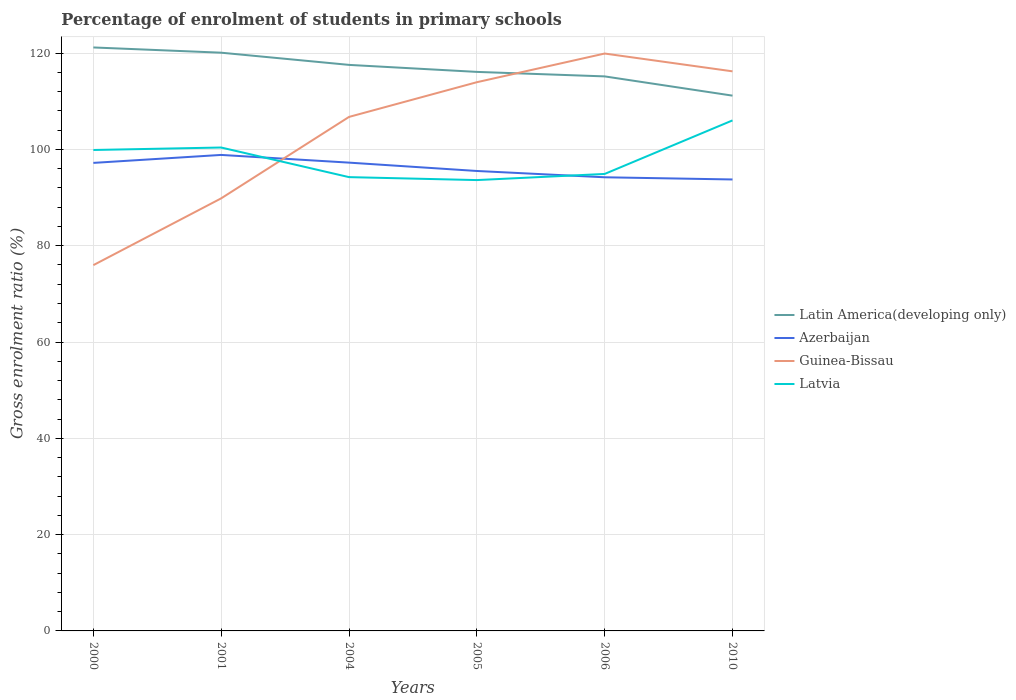How many different coloured lines are there?
Give a very brief answer. 4. Does the line corresponding to Guinea-Bissau intersect with the line corresponding to Latin America(developing only)?
Your answer should be very brief. Yes. Across all years, what is the maximum percentage of students enrolled in primary schools in Latin America(developing only)?
Keep it short and to the point. 111.17. In which year was the percentage of students enrolled in primary schools in Azerbaijan maximum?
Provide a short and direct response. 2010. What is the total percentage of students enrolled in primary schools in Latvia in the graph?
Your answer should be compact. -11.12. What is the difference between the highest and the second highest percentage of students enrolled in primary schools in Latvia?
Ensure brevity in your answer.  12.39. How many lines are there?
Your answer should be compact. 4. How many years are there in the graph?
Ensure brevity in your answer.  6. Are the values on the major ticks of Y-axis written in scientific E-notation?
Your answer should be very brief. No. Where does the legend appear in the graph?
Your response must be concise. Center right. What is the title of the graph?
Your response must be concise. Percentage of enrolment of students in primary schools. What is the label or title of the X-axis?
Ensure brevity in your answer.  Years. What is the Gross enrolment ratio (%) in Latin America(developing only) in 2000?
Your answer should be very brief. 121.18. What is the Gross enrolment ratio (%) in Azerbaijan in 2000?
Ensure brevity in your answer.  97.21. What is the Gross enrolment ratio (%) in Guinea-Bissau in 2000?
Ensure brevity in your answer.  75.97. What is the Gross enrolment ratio (%) in Latvia in 2000?
Provide a succinct answer. 99.89. What is the Gross enrolment ratio (%) in Latin America(developing only) in 2001?
Offer a terse response. 120.09. What is the Gross enrolment ratio (%) of Azerbaijan in 2001?
Make the answer very short. 98.86. What is the Gross enrolment ratio (%) in Guinea-Bissau in 2001?
Offer a terse response. 89.84. What is the Gross enrolment ratio (%) in Latvia in 2001?
Keep it short and to the point. 100.4. What is the Gross enrolment ratio (%) in Latin America(developing only) in 2004?
Your response must be concise. 117.56. What is the Gross enrolment ratio (%) in Azerbaijan in 2004?
Provide a short and direct response. 97.26. What is the Gross enrolment ratio (%) of Guinea-Bissau in 2004?
Make the answer very short. 106.76. What is the Gross enrolment ratio (%) of Latvia in 2004?
Provide a short and direct response. 94.25. What is the Gross enrolment ratio (%) of Latin America(developing only) in 2005?
Your response must be concise. 116.11. What is the Gross enrolment ratio (%) of Azerbaijan in 2005?
Offer a very short reply. 95.53. What is the Gross enrolment ratio (%) in Guinea-Bissau in 2005?
Provide a succinct answer. 113.96. What is the Gross enrolment ratio (%) in Latvia in 2005?
Your answer should be very brief. 93.64. What is the Gross enrolment ratio (%) of Latin America(developing only) in 2006?
Make the answer very short. 115.17. What is the Gross enrolment ratio (%) in Azerbaijan in 2006?
Provide a short and direct response. 94.22. What is the Gross enrolment ratio (%) in Guinea-Bissau in 2006?
Your answer should be very brief. 119.92. What is the Gross enrolment ratio (%) in Latvia in 2006?
Offer a terse response. 94.91. What is the Gross enrolment ratio (%) of Latin America(developing only) in 2010?
Make the answer very short. 111.17. What is the Gross enrolment ratio (%) of Azerbaijan in 2010?
Make the answer very short. 93.76. What is the Gross enrolment ratio (%) of Guinea-Bissau in 2010?
Provide a short and direct response. 116.22. What is the Gross enrolment ratio (%) of Latvia in 2010?
Your response must be concise. 106.03. Across all years, what is the maximum Gross enrolment ratio (%) of Latin America(developing only)?
Provide a succinct answer. 121.18. Across all years, what is the maximum Gross enrolment ratio (%) of Azerbaijan?
Provide a succinct answer. 98.86. Across all years, what is the maximum Gross enrolment ratio (%) in Guinea-Bissau?
Provide a succinct answer. 119.92. Across all years, what is the maximum Gross enrolment ratio (%) of Latvia?
Provide a succinct answer. 106.03. Across all years, what is the minimum Gross enrolment ratio (%) in Latin America(developing only)?
Ensure brevity in your answer.  111.17. Across all years, what is the minimum Gross enrolment ratio (%) of Azerbaijan?
Make the answer very short. 93.76. Across all years, what is the minimum Gross enrolment ratio (%) of Guinea-Bissau?
Give a very brief answer. 75.97. Across all years, what is the minimum Gross enrolment ratio (%) of Latvia?
Give a very brief answer. 93.64. What is the total Gross enrolment ratio (%) in Latin America(developing only) in the graph?
Offer a very short reply. 701.29. What is the total Gross enrolment ratio (%) of Azerbaijan in the graph?
Your response must be concise. 576.84. What is the total Gross enrolment ratio (%) in Guinea-Bissau in the graph?
Offer a terse response. 622.67. What is the total Gross enrolment ratio (%) of Latvia in the graph?
Your response must be concise. 589.12. What is the difference between the Gross enrolment ratio (%) of Latin America(developing only) in 2000 and that in 2001?
Your answer should be compact. 1.09. What is the difference between the Gross enrolment ratio (%) in Azerbaijan in 2000 and that in 2001?
Give a very brief answer. -1.65. What is the difference between the Gross enrolment ratio (%) in Guinea-Bissau in 2000 and that in 2001?
Provide a succinct answer. -13.87. What is the difference between the Gross enrolment ratio (%) of Latvia in 2000 and that in 2001?
Make the answer very short. -0.51. What is the difference between the Gross enrolment ratio (%) of Latin America(developing only) in 2000 and that in 2004?
Offer a terse response. 3.62. What is the difference between the Gross enrolment ratio (%) in Azerbaijan in 2000 and that in 2004?
Ensure brevity in your answer.  -0.05. What is the difference between the Gross enrolment ratio (%) of Guinea-Bissau in 2000 and that in 2004?
Keep it short and to the point. -30.79. What is the difference between the Gross enrolment ratio (%) of Latvia in 2000 and that in 2004?
Keep it short and to the point. 5.64. What is the difference between the Gross enrolment ratio (%) in Latin America(developing only) in 2000 and that in 2005?
Provide a succinct answer. 5.07. What is the difference between the Gross enrolment ratio (%) of Azerbaijan in 2000 and that in 2005?
Offer a terse response. 1.68. What is the difference between the Gross enrolment ratio (%) in Guinea-Bissau in 2000 and that in 2005?
Offer a terse response. -37.99. What is the difference between the Gross enrolment ratio (%) of Latvia in 2000 and that in 2005?
Offer a very short reply. 6.25. What is the difference between the Gross enrolment ratio (%) in Latin America(developing only) in 2000 and that in 2006?
Your answer should be compact. 6.01. What is the difference between the Gross enrolment ratio (%) of Azerbaijan in 2000 and that in 2006?
Ensure brevity in your answer.  2.99. What is the difference between the Gross enrolment ratio (%) in Guinea-Bissau in 2000 and that in 2006?
Keep it short and to the point. -43.95. What is the difference between the Gross enrolment ratio (%) in Latvia in 2000 and that in 2006?
Your answer should be very brief. 4.97. What is the difference between the Gross enrolment ratio (%) in Latin America(developing only) in 2000 and that in 2010?
Offer a very short reply. 10.01. What is the difference between the Gross enrolment ratio (%) in Azerbaijan in 2000 and that in 2010?
Make the answer very short. 3.45. What is the difference between the Gross enrolment ratio (%) in Guinea-Bissau in 2000 and that in 2010?
Provide a short and direct response. -40.25. What is the difference between the Gross enrolment ratio (%) in Latvia in 2000 and that in 2010?
Make the answer very short. -6.15. What is the difference between the Gross enrolment ratio (%) of Latin America(developing only) in 2001 and that in 2004?
Offer a very short reply. 2.53. What is the difference between the Gross enrolment ratio (%) in Azerbaijan in 2001 and that in 2004?
Keep it short and to the point. 1.6. What is the difference between the Gross enrolment ratio (%) in Guinea-Bissau in 2001 and that in 2004?
Make the answer very short. -16.91. What is the difference between the Gross enrolment ratio (%) in Latvia in 2001 and that in 2004?
Make the answer very short. 6.15. What is the difference between the Gross enrolment ratio (%) in Latin America(developing only) in 2001 and that in 2005?
Your answer should be very brief. 3.99. What is the difference between the Gross enrolment ratio (%) in Azerbaijan in 2001 and that in 2005?
Make the answer very short. 3.33. What is the difference between the Gross enrolment ratio (%) of Guinea-Bissau in 2001 and that in 2005?
Ensure brevity in your answer.  -24.12. What is the difference between the Gross enrolment ratio (%) of Latvia in 2001 and that in 2005?
Ensure brevity in your answer.  6.76. What is the difference between the Gross enrolment ratio (%) in Latin America(developing only) in 2001 and that in 2006?
Provide a short and direct response. 4.92. What is the difference between the Gross enrolment ratio (%) of Azerbaijan in 2001 and that in 2006?
Give a very brief answer. 4.64. What is the difference between the Gross enrolment ratio (%) of Guinea-Bissau in 2001 and that in 2006?
Your answer should be very brief. -30.08. What is the difference between the Gross enrolment ratio (%) in Latvia in 2001 and that in 2006?
Provide a succinct answer. 5.49. What is the difference between the Gross enrolment ratio (%) in Latin America(developing only) in 2001 and that in 2010?
Provide a short and direct response. 8.92. What is the difference between the Gross enrolment ratio (%) of Azerbaijan in 2001 and that in 2010?
Your answer should be very brief. 5.1. What is the difference between the Gross enrolment ratio (%) of Guinea-Bissau in 2001 and that in 2010?
Your answer should be very brief. -26.38. What is the difference between the Gross enrolment ratio (%) in Latvia in 2001 and that in 2010?
Give a very brief answer. -5.63. What is the difference between the Gross enrolment ratio (%) of Latin America(developing only) in 2004 and that in 2005?
Offer a terse response. 1.45. What is the difference between the Gross enrolment ratio (%) in Azerbaijan in 2004 and that in 2005?
Give a very brief answer. 1.73. What is the difference between the Gross enrolment ratio (%) in Guinea-Bissau in 2004 and that in 2005?
Your response must be concise. -7.21. What is the difference between the Gross enrolment ratio (%) in Latvia in 2004 and that in 2005?
Offer a very short reply. 0.61. What is the difference between the Gross enrolment ratio (%) in Latin America(developing only) in 2004 and that in 2006?
Give a very brief answer. 2.39. What is the difference between the Gross enrolment ratio (%) in Azerbaijan in 2004 and that in 2006?
Your answer should be very brief. 3.04. What is the difference between the Gross enrolment ratio (%) in Guinea-Bissau in 2004 and that in 2006?
Your answer should be compact. -13.16. What is the difference between the Gross enrolment ratio (%) of Latvia in 2004 and that in 2006?
Provide a short and direct response. -0.66. What is the difference between the Gross enrolment ratio (%) of Latin America(developing only) in 2004 and that in 2010?
Give a very brief answer. 6.39. What is the difference between the Gross enrolment ratio (%) of Azerbaijan in 2004 and that in 2010?
Provide a short and direct response. 3.5. What is the difference between the Gross enrolment ratio (%) in Guinea-Bissau in 2004 and that in 2010?
Give a very brief answer. -9.47. What is the difference between the Gross enrolment ratio (%) of Latvia in 2004 and that in 2010?
Your answer should be very brief. -11.78. What is the difference between the Gross enrolment ratio (%) in Latin America(developing only) in 2005 and that in 2006?
Offer a terse response. 0.93. What is the difference between the Gross enrolment ratio (%) of Azerbaijan in 2005 and that in 2006?
Provide a succinct answer. 1.31. What is the difference between the Gross enrolment ratio (%) of Guinea-Bissau in 2005 and that in 2006?
Give a very brief answer. -5.95. What is the difference between the Gross enrolment ratio (%) of Latvia in 2005 and that in 2006?
Ensure brevity in your answer.  -1.27. What is the difference between the Gross enrolment ratio (%) of Latin America(developing only) in 2005 and that in 2010?
Your answer should be very brief. 4.93. What is the difference between the Gross enrolment ratio (%) of Azerbaijan in 2005 and that in 2010?
Provide a short and direct response. 1.76. What is the difference between the Gross enrolment ratio (%) of Guinea-Bissau in 2005 and that in 2010?
Offer a terse response. -2.26. What is the difference between the Gross enrolment ratio (%) of Latvia in 2005 and that in 2010?
Keep it short and to the point. -12.39. What is the difference between the Gross enrolment ratio (%) in Latin America(developing only) in 2006 and that in 2010?
Give a very brief answer. 4. What is the difference between the Gross enrolment ratio (%) of Azerbaijan in 2006 and that in 2010?
Give a very brief answer. 0.45. What is the difference between the Gross enrolment ratio (%) of Guinea-Bissau in 2006 and that in 2010?
Give a very brief answer. 3.7. What is the difference between the Gross enrolment ratio (%) in Latvia in 2006 and that in 2010?
Make the answer very short. -11.12. What is the difference between the Gross enrolment ratio (%) of Latin America(developing only) in 2000 and the Gross enrolment ratio (%) of Azerbaijan in 2001?
Your answer should be compact. 22.32. What is the difference between the Gross enrolment ratio (%) in Latin America(developing only) in 2000 and the Gross enrolment ratio (%) in Guinea-Bissau in 2001?
Keep it short and to the point. 31.34. What is the difference between the Gross enrolment ratio (%) of Latin America(developing only) in 2000 and the Gross enrolment ratio (%) of Latvia in 2001?
Your answer should be compact. 20.78. What is the difference between the Gross enrolment ratio (%) of Azerbaijan in 2000 and the Gross enrolment ratio (%) of Guinea-Bissau in 2001?
Give a very brief answer. 7.37. What is the difference between the Gross enrolment ratio (%) in Azerbaijan in 2000 and the Gross enrolment ratio (%) in Latvia in 2001?
Offer a very short reply. -3.19. What is the difference between the Gross enrolment ratio (%) in Guinea-Bissau in 2000 and the Gross enrolment ratio (%) in Latvia in 2001?
Your answer should be compact. -24.43. What is the difference between the Gross enrolment ratio (%) of Latin America(developing only) in 2000 and the Gross enrolment ratio (%) of Azerbaijan in 2004?
Make the answer very short. 23.92. What is the difference between the Gross enrolment ratio (%) of Latin America(developing only) in 2000 and the Gross enrolment ratio (%) of Guinea-Bissau in 2004?
Provide a short and direct response. 14.43. What is the difference between the Gross enrolment ratio (%) of Latin America(developing only) in 2000 and the Gross enrolment ratio (%) of Latvia in 2004?
Your response must be concise. 26.93. What is the difference between the Gross enrolment ratio (%) of Azerbaijan in 2000 and the Gross enrolment ratio (%) of Guinea-Bissau in 2004?
Make the answer very short. -9.55. What is the difference between the Gross enrolment ratio (%) in Azerbaijan in 2000 and the Gross enrolment ratio (%) in Latvia in 2004?
Offer a terse response. 2.96. What is the difference between the Gross enrolment ratio (%) of Guinea-Bissau in 2000 and the Gross enrolment ratio (%) of Latvia in 2004?
Your response must be concise. -18.28. What is the difference between the Gross enrolment ratio (%) of Latin America(developing only) in 2000 and the Gross enrolment ratio (%) of Azerbaijan in 2005?
Offer a very short reply. 25.65. What is the difference between the Gross enrolment ratio (%) of Latin America(developing only) in 2000 and the Gross enrolment ratio (%) of Guinea-Bissau in 2005?
Give a very brief answer. 7.22. What is the difference between the Gross enrolment ratio (%) in Latin America(developing only) in 2000 and the Gross enrolment ratio (%) in Latvia in 2005?
Provide a short and direct response. 27.54. What is the difference between the Gross enrolment ratio (%) of Azerbaijan in 2000 and the Gross enrolment ratio (%) of Guinea-Bissau in 2005?
Offer a very short reply. -16.76. What is the difference between the Gross enrolment ratio (%) of Azerbaijan in 2000 and the Gross enrolment ratio (%) of Latvia in 2005?
Offer a very short reply. 3.57. What is the difference between the Gross enrolment ratio (%) of Guinea-Bissau in 2000 and the Gross enrolment ratio (%) of Latvia in 2005?
Make the answer very short. -17.67. What is the difference between the Gross enrolment ratio (%) of Latin America(developing only) in 2000 and the Gross enrolment ratio (%) of Azerbaijan in 2006?
Make the answer very short. 26.96. What is the difference between the Gross enrolment ratio (%) in Latin America(developing only) in 2000 and the Gross enrolment ratio (%) in Guinea-Bissau in 2006?
Your answer should be very brief. 1.26. What is the difference between the Gross enrolment ratio (%) in Latin America(developing only) in 2000 and the Gross enrolment ratio (%) in Latvia in 2006?
Offer a terse response. 26.27. What is the difference between the Gross enrolment ratio (%) in Azerbaijan in 2000 and the Gross enrolment ratio (%) in Guinea-Bissau in 2006?
Offer a very short reply. -22.71. What is the difference between the Gross enrolment ratio (%) in Azerbaijan in 2000 and the Gross enrolment ratio (%) in Latvia in 2006?
Your answer should be very brief. 2.3. What is the difference between the Gross enrolment ratio (%) of Guinea-Bissau in 2000 and the Gross enrolment ratio (%) of Latvia in 2006?
Ensure brevity in your answer.  -18.94. What is the difference between the Gross enrolment ratio (%) of Latin America(developing only) in 2000 and the Gross enrolment ratio (%) of Azerbaijan in 2010?
Your response must be concise. 27.42. What is the difference between the Gross enrolment ratio (%) of Latin America(developing only) in 2000 and the Gross enrolment ratio (%) of Guinea-Bissau in 2010?
Ensure brevity in your answer.  4.96. What is the difference between the Gross enrolment ratio (%) of Latin America(developing only) in 2000 and the Gross enrolment ratio (%) of Latvia in 2010?
Provide a succinct answer. 15.15. What is the difference between the Gross enrolment ratio (%) in Azerbaijan in 2000 and the Gross enrolment ratio (%) in Guinea-Bissau in 2010?
Offer a very short reply. -19.01. What is the difference between the Gross enrolment ratio (%) of Azerbaijan in 2000 and the Gross enrolment ratio (%) of Latvia in 2010?
Offer a very short reply. -8.82. What is the difference between the Gross enrolment ratio (%) in Guinea-Bissau in 2000 and the Gross enrolment ratio (%) in Latvia in 2010?
Keep it short and to the point. -30.06. What is the difference between the Gross enrolment ratio (%) in Latin America(developing only) in 2001 and the Gross enrolment ratio (%) in Azerbaijan in 2004?
Ensure brevity in your answer.  22.83. What is the difference between the Gross enrolment ratio (%) in Latin America(developing only) in 2001 and the Gross enrolment ratio (%) in Guinea-Bissau in 2004?
Ensure brevity in your answer.  13.34. What is the difference between the Gross enrolment ratio (%) of Latin America(developing only) in 2001 and the Gross enrolment ratio (%) of Latvia in 2004?
Your response must be concise. 25.84. What is the difference between the Gross enrolment ratio (%) of Azerbaijan in 2001 and the Gross enrolment ratio (%) of Guinea-Bissau in 2004?
Provide a short and direct response. -7.89. What is the difference between the Gross enrolment ratio (%) in Azerbaijan in 2001 and the Gross enrolment ratio (%) in Latvia in 2004?
Offer a terse response. 4.61. What is the difference between the Gross enrolment ratio (%) in Guinea-Bissau in 2001 and the Gross enrolment ratio (%) in Latvia in 2004?
Ensure brevity in your answer.  -4.41. What is the difference between the Gross enrolment ratio (%) of Latin America(developing only) in 2001 and the Gross enrolment ratio (%) of Azerbaijan in 2005?
Give a very brief answer. 24.57. What is the difference between the Gross enrolment ratio (%) in Latin America(developing only) in 2001 and the Gross enrolment ratio (%) in Guinea-Bissau in 2005?
Offer a very short reply. 6.13. What is the difference between the Gross enrolment ratio (%) of Latin America(developing only) in 2001 and the Gross enrolment ratio (%) of Latvia in 2005?
Your answer should be compact. 26.46. What is the difference between the Gross enrolment ratio (%) of Azerbaijan in 2001 and the Gross enrolment ratio (%) of Guinea-Bissau in 2005?
Your answer should be very brief. -15.1. What is the difference between the Gross enrolment ratio (%) in Azerbaijan in 2001 and the Gross enrolment ratio (%) in Latvia in 2005?
Make the answer very short. 5.22. What is the difference between the Gross enrolment ratio (%) of Guinea-Bissau in 2001 and the Gross enrolment ratio (%) of Latvia in 2005?
Your response must be concise. -3.79. What is the difference between the Gross enrolment ratio (%) of Latin America(developing only) in 2001 and the Gross enrolment ratio (%) of Azerbaijan in 2006?
Ensure brevity in your answer.  25.88. What is the difference between the Gross enrolment ratio (%) of Latin America(developing only) in 2001 and the Gross enrolment ratio (%) of Guinea-Bissau in 2006?
Offer a very short reply. 0.17. What is the difference between the Gross enrolment ratio (%) of Latin America(developing only) in 2001 and the Gross enrolment ratio (%) of Latvia in 2006?
Provide a succinct answer. 25.18. What is the difference between the Gross enrolment ratio (%) of Azerbaijan in 2001 and the Gross enrolment ratio (%) of Guinea-Bissau in 2006?
Your answer should be compact. -21.06. What is the difference between the Gross enrolment ratio (%) of Azerbaijan in 2001 and the Gross enrolment ratio (%) of Latvia in 2006?
Keep it short and to the point. 3.95. What is the difference between the Gross enrolment ratio (%) in Guinea-Bissau in 2001 and the Gross enrolment ratio (%) in Latvia in 2006?
Provide a short and direct response. -5.07. What is the difference between the Gross enrolment ratio (%) of Latin America(developing only) in 2001 and the Gross enrolment ratio (%) of Azerbaijan in 2010?
Give a very brief answer. 26.33. What is the difference between the Gross enrolment ratio (%) in Latin America(developing only) in 2001 and the Gross enrolment ratio (%) in Guinea-Bissau in 2010?
Your answer should be compact. 3.87. What is the difference between the Gross enrolment ratio (%) in Latin America(developing only) in 2001 and the Gross enrolment ratio (%) in Latvia in 2010?
Provide a short and direct response. 14.06. What is the difference between the Gross enrolment ratio (%) in Azerbaijan in 2001 and the Gross enrolment ratio (%) in Guinea-Bissau in 2010?
Your answer should be compact. -17.36. What is the difference between the Gross enrolment ratio (%) of Azerbaijan in 2001 and the Gross enrolment ratio (%) of Latvia in 2010?
Keep it short and to the point. -7.17. What is the difference between the Gross enrolment ratio (%) of Guinea-Bissau in 2001 and the Gross enrolment ratio (%) of Latvia in 2010?
Provide a short and direct response. -16.19. What is the difference between the Gross enrolment ratio (%) in Latin America(developing only) in 2004 and the Gross enrolment ratio (%) in Azerbaijan in 2005?
Give a very brief answer. 22.03. What is the difference between the Gross enrolment ratio (%) in Latin America(developing only) in 2004 and the Gross enrolment ratio (%) in Guinea-Bissau in 2005?
Keep it short and to the point. 3.6. What is the difference between the Gross enrolment ratio (%) in Latin America(developing only) in 2004 and the Gross enrolment ratio (%) in Latvia in 2005?
Your response must be concise. 23.92. What is the difference between the Gross enrolment ratio (%) in Azerbaijan in 2004 and the Gross enrolment ratio (%) in Guinea-Bissau in 2005?
Give a very brief answer. -16.7. What is the difference between the Gross enrolment ratio (%) in Azerbaijan in 2004 and the Gross enrolment ratio (%) in Latvia in 2005?
Ensure brevity in your answer.  3.62. What is the difference between the Gross enrolment ratio (%) in Guinea-Bissau in 2004 and the Gross enrolment ratio (%) in Latvia in 2005?
Provide a succinct answer. 13.12. What is the difference between the Gross enrolment ratio (%) of Latin America(developing only) in 2004 and the Gross enrolment ratio (%) of Azerbaijan in 2006?
Keep it short and to the point. 23.34. What is the difference between the Gross enrolment ratio (%) of Latin America(developing only) in 2004 and the Gross enrolment ratio (%) of Guinea-Bissau in 2006?
Your response must be concise. -2.36. What is the difference between the Gross enrolment ratio (%) of Latin America(developing only) in 2004 and the Gross enrolment ratio (%) of Latvia in 2006?
Ensure brevity in your answer.  22.65. What is the difference between the Gross enrolment ratio (%) of Azerbaijan in 2004 and the Gross enrolment ratio (%) of Guinea-Bissau in 2006?
Your response must be concise. -22.66. What is the difference between the Gross enrolment ratio (%) in Azerbaijan in 2004 and the Gross enrolment ratio (%) in Latvia in 2006?
Provide a succinct answer. 2.35. What is the difference between the Gross enrolment ratio (%) in Guinea-Bissau in 2004 and the Gross enrolment ratio (%) in Latvia in 2006?
Offer a terse response. 11.84. What is the difference between the Gross enrolment ratio (%) in Latin America(developing only) in 2004 and the Gross enrolment ratio (%) in Azerbaijan in 2010?
Provide a succinct answer. 23.8. What is the difference between the Gross enrolment ratio (%) of Latin America(developing only) in 2004 and the Gross enrolment ratio (%) of Guinea-Bissau in 2010?
Ensure brevity in your answer.  1.34. What is the difference between the Gross enrolment ratio (%) of Latin America(developing only) in 2004 and the Gross enrolment ratio (%) of Latvia in 2010?
Your answer should be compact. 11.53. What is the difference between the Gross enrolment ratio (%) in Azerbaijan in 2004 and the Gross enrolment ratio (%) in Guinea-Bissau in 2010?
Offer a very short reply. -18.96. What is the difference between the Gross enrolment ratio (%) in Azerbaijan in 2004 and the Gross enrolment ratio (%) in Latvia in 2010?
Offer a terse response. -8.77. What is the difference between the Gross enrolment ratio (%) in Guinea-Bissau in 2004 and the Gross enrolment ratio (%) in Latvia in 2010?
Your response must be concise. 0.72. What is the difference between the Gross enrolment ratio (%) in Latin America(developing only) in 2005 and the Gross enrolment ratio (%) in Azerbaijan in 2006?
Your answer should be very brief. 21.89. What is the difference between the Gross enrolment ratio (%) in Latin America(developing only) in 2005 and the Gross enrolment ratio (%) in Guinea-Bissau in 2006?
Your answer should be compact. -3.81. What is the difference between the Gross enrolment ratio (%) in Latin America(developing only) in 2005 and the Gross enrolment ratio (%) in Latvia in 2006?
Your answer should be compact. 21.19. What is the difference between the Gross enrolment ratio (%) in Azerbaijan in 2005 and the Gross enrolment ratio (%) in Guinea-Bissau in 2006?
Make the answer very short. -24.39. What is the difference between the Gross enrolment ratio (%) in Azerbaijan in 2005 and the Gross enrolment ratio (%) in Latvia in 2006?
Keep it short and to the point. 0.61. What is the difference between the Gross enrolment ratio (%) of Guinea-Bissau in 2005 and the Gross enrolment ratio (%) of Latvia in 2006?
Your answer should be compact. 19.05. What is the difference between the Gross enrolment ratio (%) of Latin America(developing only) in 2005 and the Gross enrolment ratio (%) of Azerbaijan in 2010?
Provide a succinct answer. 22.34. What is the difference between the Gross enrolment ratio (%) of Latin America(developing only) in 2005 and the Gross enrolment ratio (%) of Guinea-Bissau in 2010?
Provide a succinct answer. -0.11. What is the difference between the Gross enrolment ratio (%) in Latin America(developing only) in 2005 and the Gross enrolment ratio (%) in Latvia in 2010?
Keep it short and to the point. 10.08. What is the difference between the Gross enrolment ratio (%) of Azerbaijan in 2005 and the Gross enrolment ratio (%) of Guinea-Bissau in 2010?
Ensure brevity in your answer.  -20.69. What is the difference between the Gross enrolment ratio (%) in Azerbaijan in 2005 and the Gross enrolment ratio (%) in Latvia in 2010?
Make the answer very short. -10.5. What is the difference between the Gross enrolment ratio (%) of Guinea-Bissau in 2005 and the Gross enrolment ratio (%) of Latvia in 2010?
Make the answer very short. 7.93. What is the difference between the Gross enrolment ratio (%) of Latin America(developing only) in 2006 and the Gross enrolment ratio (%) of Azerbaijan in 2010?
Your response must be concise. 21.41. What is the difference between the Gross enrolment ratio (%) in Latin America(developing only) in 2006 and the Gross enrolment ratio (%) in Guinea-Bissau in 2010?
Keep it short and to the point. -1.05. What is the difference between the Gross enrolment ratio (%) of Latin America(developing only) in 2006 and the Gross enrolment ratio (%) of Latvia in 2010?
Your answer should be compact. 9.14. What is the difference between the Gross enrolment ratio (%) in Azerbaijan in 2006 and the Gross enrolment ratio (%) in Guinea-Bissau in 2010?
Provide a succinct answer. -22. What is the difference between the Gross enrolment ratio (%) in Azerbaijan in 2006 and the Gross enrolment ratio (%) in Latvia in 2010?
Provide a succinct answer. -11.81. What is the difference between the Gross enrolment ratio (%) in Guinea-Bissau in 2006 and the Gross enrolment ratio (%) in Latvia in 2010?
Offer a terse response. 13.89. What is the average Gross enrolment ratio (%) of Latin America(developing only) per year?
Your answer should be compact. 116.88. What is the average Gross enrolment ratio (%) of Azerbaijan per year?
Your answer should be very brief. 96.14. What is the average Gross enrolment ratio (%) in Guinea-Bissau per year?
Give a very brief answer. 103.78. What is the average Gross enrolment ratio (%) in Latvia per year?
Give a very brief answer. 98.19. In the year 2000, what is the difference between the Gross enrolment ratio (%) in Latin America(developing only) and Gross enrolment ratio (%) in Azerbaijan?
Give a very brief answer. 23.97. In the year 2000, what is the difference between the Gross enrolment ratio (%) in Latin America(developing only) and Gross enrolment ratio (%) in Guinea-Bissau?
Provide a short and direct response. 45.21. In the year 2000, what is the difference between the Gross enrolment ratio (%) in Latin America(developing only) and Gross enrolment ratio (%) in Latvia?
Offer a terse response. 21.29. In the year 2000, what is the difference between the Gross enrolment ratio (%) in Azerbaijan and Gross enrolment ratio (%) in Guinea-Bissau?
Your answer should be very brief. 21.24. In the year 2000, what is the difference between the Gross enrolment ratio (%) of Azerbaijan and Gross enrolment ratio (%) of Latvia?
Make the answer very short. -2.68. In the year 2000, what is the difference between the Gross enrolment ratio (%) in Guinea-Bissau and Gross enrolment ratio (%) in Latvia?
Your answer should be compact. -23.92. In the year 2001, what is the difference between the Gross enrolment ratio (%) in Latin America(developing only) and Gross enrolment ratio (%) in Azerbaijan?
Provide a short and direct response. 21.23. In the year 2001, what is the difference between the Gross enrolment ratio (%) in Latin America(developing only) and Gross enrolment ratio (%) in Guinea-Bissau?
Offer a very short reply. 30.25. In the year 2001, what is the difference between the Gross enrolment ratio (%) of Latin America(developing only) and Gross enrolment ratio (%) of Latvia?
Make the answer very short. 19.69. In the year 2001, what is the difference between the Gross enrolment ratio (%) of Azerbaijan and Gross enrolment ratio (%) of Guinea-Bissau?
Keep it short and to the point. 9.02. In the year 2001, what is the difference between the Gross enrolment ratio (%) in Azerbaijan and Gross enrolment ratio (%) in Latvia?
Ensure brevity in your answer.  -1.54. In the year 2001, what is the difference between the Gross enrolment ratio (%) of Guinea-Bissau and Gross enrolment ratio (%) of Latvia?
Keep it short and to the point. -10.56. In the year 2004, what is the difference between the Gross enrolment ratio (%) of Latin America(developing only) and Gross enrolment ratio (%) of Azerbaijan?
Your response must be concise. 20.3. In the year 2004, what is the difference between the Gross enrolment ratio (%) in Latin America(developing only) and Gross enrolment ratio (%) in Guinea-Bissau?
Offer a very short reply. 10.81. In the year 2004, what is the difference between the Gross enrolment ratio (%) in Latin America(developing only) and Gross enrolment ratio (%) in Latvia?
Your response must be concise. 23.31. In the year 2004, what is the difference between the Gross enrolment ratio (%) in Azerbaijan and Gross enrolment ratio (%) in Guinea-Bissau?
Make the answer very short. -9.49. In the year 2004, what is the difference between the Gross enrolment ratio (%) of Azerbaijan and Gross enrolment ratio (%) of Latvia?
Offer a terse response. 3.01. In the year 2004, what is the difference between the Gross enrolment ratio (%) of Guinea-Bissau and Gross enrolment ratio (%) of Latvia?
Your answer should be very brief. 12.5. In the year 2005, what is the difference between the Gross enrolment ratio (%) of Latin America(developing only) and Gross enrolment ratio (%) of Azerbaijan?
Provide a succinct answer. 20.58. In the year 2005, what is the difference between the Gross enrolment ratio (%) of Latin America(developing only) and Gross enrolment ratio (%) of Guinea-Bissau?
Your response must be concise. 2.14. In the year 2005, what is the difference between the Gross enrolment ratio (%) in Latin America(developing only) and Gross enrolment ratio (%) in Latvia?
Your response must be concise. 22.47. In the year 2005, what is the difference between the Gross enrolment ratio (%) in Azerbaijan and Gross enrolment ratio (%) in Guinea-Bissau?
Offer a terse response. -18.44. In the year 2005, what is the difference between the Gross enrolment ratio (%) in Azerbaijan and Gross enrolment ratio (%) in Latvia?
Provide a short and direct response. 1.89. In the year 2005, what is the difference between the Gross enrolment ratio (%) in Guinea-Bissau and Gross enrolment ratio (%) in Latvia?
Offer a very short reply. 20.33. In the year 2006, what is the difference between the Gross enrolment ratio (%) in Latin America(developing only) and Gross enrolment ratio (%) in Azerbaijan?
Provide a succinct answer. 20.96. In the year 2006, what is the difference between the Gross enrolment ratio (%) of Latin America(developing only) and Gross enrolment ratio (%) of Guinea-Bissau?
Your response must be concise. -4.75. In the year 2006, what is the difference between the Gross enrolment ratio (%) in Latin America(developing only) and Gross enrolment ratio (%) in Latvia?
Offer a terse response. 20.26. In the year 2006, what is the difference between the Gross enrolment ratio (%) of Azerbaijan and Gross enrolment ratio (%) of Guinea-Bissau?
Keep it short and to the point. -25.7. In the year 2006, what is the difference between the Gross enrolment ratio (%) of Azerbaijan and Gross enrolment ratio (%) of Latvia?
Your answer should be very brief. -0.7. In the year 2006, what is the difference between the Gross enrolment ratio (%) in Guinea-Bissau and Gross enrolment ratio (%) in Latvia?
Your answer should be compact. 25.01. In the year 2010, what is the difference between the Gross enrolment ratio (%) in Latin America(developing only) and Gross enrolment ratio (%) in Azerbaijan?
Keep it short and to the point. 17.41. In the year 2010, what is the difference between the Gross enrolment ratio (%) in Latin America(developing only) and Gross enrolment ratio (%) in Guinea-Bissau?
Provide a succinct answer. -5.05. In the year 2010, what is the difference between the Gross enrolment ratio (%) in Latin America(developing only) and Gross enrolment ratio (%) in Latvia?
Provide a succinct answer. 5.14. In the year 2010, what is the difference between the Gross enrolment ratio (%) of Azerbaijan and Gross enrolment ratio (%) of Guinea-Bissau?
Make the answer very short. -22.46. In the year 2010, what is the difference between the Gross enrolment ratio (%) of Azerbaijan and Gross enrolment ratio (%) of Latvia?
Offer a terse response. -12.27. In the year 2010, what is the difference between the Gross enrolment ratio (%) in Guinea-Bissau and Gross enrolment ratio (%) in Latvia?
Your response must be concise. 10.19. What is the ratio of the Gross enrolment ratio (%) of Latin America(developing only) in 2000 to that in 2001?
Provide a short and direct response. 1.01. What is the ratio of the Gross enrolment ratio (%) in Azerbaijan in 2000 to that in 2001?
Offer a terse response. 0.98. What is the ratio of the Gross enrolment ratio (%) in Guinea-Bissau in 2000 to that in 2001?
Your response must be concise. 0.85. What is the ratio of the Gross enrolment ratio (%) of Latin America(developing only) in 2000 to that in 2004?
Offer a terse response. 1.03. What is the ratio of the Gross enrolment ratio (%) in Azerbaijan in 2000 to that in 2004?
Make the answer very short. 1. What is the ratio of the Gross enrolment ratio (%) in Guinea-Bissau in 2000 to that in 2004?
Provide a short and direct response. 0.71. What is the ratio of the Gross enrolment ratio (%) in Latvia in 2000 to that in 2004?
Provide a succinct answer. 1.06. What is the ratio of the Gross enrolment ratio (%) of Latin America(developing only) in 2000 to that in 2005?
Give a very brief answer. 1.04. What is the ratio of the Gross enrolment ratio (%) in Azerbaijan in 2000 to that in 2005?
Your response must be concise. 1.02. What is the ratio of the Gross enrolment ratio (%) in Guinea-Bissau in 2000 to that in 2005?
Offer a very short reply. 0.67. What is the ratio of the Gross enrolment ratio (%) of Latvia in 2000 to that in 2005?
Your answer should be very brief. 1.07. What is the ratio of the Gross enrolment ratio (%) in Latin America(developing only) in 2000 to that in 2006?
Your answer should be very brief. 1.05. What is the ratio of the Gross enrolment ratio (%) of Azerbaijan in 2000 to that in 2006?
Offer a terse response. 1.03. What is the ratio of the Gross enrolment ratio (%) of Guinea-Bissau in 2000 to that in 2006?
Keep it short and to the point. 0.63. What is the ratio of the Gross enrolment ratio (%) in Latvia in 2000 to that in 2006?
Offer a very short reply. 1.05. What is the ratio of the Gross enrolment ratio (%) of Latin America(developing only) in 2000 to that in 2010?
Your answer should be very brief. 1.09. What is the ratio of the Gross enrolment ratio (%) in Azerbaijan in 2000 to that in 2010?
Give a very brief answer. 1.04. What is the ratio of the Gross enrolment ratio (%) of Guinea-Bissau in 2000 to that in 2010?
Offer a terse response. 0.65. What is the ratio of the Gross enrolment ratio (%) in Latvia in 2000 to that in 2010?
Offer a very short reply. 0.94. What is the ratio of the Gross enrolment ratio (%) in Latin America(developing only) in 2001 to that in 2004?
Offer a very short reply. 1.02. What is the ratio of the Gross enrolment ratio (%) in Azerbaijan in 2001 to that in 2004?
Offer a terse response. 1.02. What is the ratio of the Gross enrolment ratio (%) of Guinea-Bissau in 2001 to that in 2004?
Your answer should be compact. 0.84. What is the ratio of the Gross enrolment ratio (%) in Latvia in 2001 to that in 2004?
Make the answer very short. 1.07. What is the ratio of the Gross enrolment ratio (%) of Latin America(developing only) in 2001 to that in 2005?
Your answer should be very brief. 1.03. What is the ratio of the Gross enrolment ratio (%) of Azerbaijan in 2001 to that in 2005?
Provide a short and direct response. 1.03. What is the ratio of the Gross enrolment ratio (%) of Guinea-Bissau in 2001 to that in 2005?
Give a very brief answer. 0.79. What is the ratio of the Gross enrolment ratio (%) in Latvia in 2001 to that in 2005?
Provide a short and direct response. 1.07. What is the ratio of the Gross enrolment ratio (%) in Latin America(developing only) in 2001 to that in 2006?
Provide a succinct answer. 1.04. What is the ratio of the Gross enrolment ratio (%) in Azerbaijan in 2001 to that in 2006?
Provide a succinct answer. 1.05. What is the ratio of the Gross enrolment ratio (%) of Guinea-Bissau in 2001 to that in 2006?
Give a very brief answer. 0.75. What is the ratio of the Gross enrolment ratio (%) in Latvia in 2001 to that in 2006?
Ensure brevity in your answer.  1.06. What is the ratio of the Gross enrolment ratio (%) in Latin America(developing only) in 2001 to that in 2010?
Your answer should be compact. 1.08. What is the ratio of the Gross enrolment ratio (%) in Azerbaijan in 2001 to that in 2010?
Provide a succinct answer. 1.05. What is the ratio of the Gross enrolment ratio (%) of Guinea-Bissau in 2001 to that in 2010?
Provide a succinct answer. 0.77. What is the ratio of the Gross enrolment ratio (%) of Latvia in 2001 to that in 2010?
Offer a terse response. 0.95. What is the ratio of the Gross enrolment ratio (%) of Latin America(developing only) in 2004 to that in 2005?
Ensure brevity in your answer.  1.01. What is the ratio of the Gross enrolment ratio (%) of Azerbaijan in 2004 to that in 2005?
Provide a succinct answer. 1.02. What is the ratio of the Gross enrolment ratio (%) in Guinea-Bissau in 2004 to that in 2005?
Make the answer very short. 0.94. What is the ratio of the Gross enrolment ratio (%) of Latvia in 2004 to that in 2005?
Offer a terse response. 1.01. What is the ratio of the Gross enrolment ratio (%) of Latin America(developing only) in 2004 to that in 2006?
Ensure brevity in your answer.  1.02. What is the ratio of the Gross enrolment ratio (%) of Azerbaijan in 2004 to that in 2006?
Provide a short and direct response. 1.03. What is the ratio of the Gross enrolment ratio (%) in Guinea-Bissau in 2004 to that in 2006?
Provide a short and direct response. 0.89. What is the ratio of the Gross enrolment ratio (%) of Latvia in 2004 to that in 2006?
Make the answer very short. 0.99. What is the ratio of the Gross enrolment ratio (%) in Latin America(developing only) in 2004 to that in 2010?
Offer a very short reply. 1.06. What is the ratio of the Gross enrolment ratio (%) of Azerbaijan in 2004 to that in 2010?
Give a very brief answer. 1.04. What is the ratio of the Gross enrolment ratio (%) in Guinea-Bissau in 2004 to that in 2010?
Make the answer very short. 0.92. What is the ratio of the Gross enrolment ratio (%) of Latvia in 2004 to that in 2010?
Provide a short and direct response. 0.89. What is the ratio of the Gross enrolment ratio (%) of Latin America(developing only) in 2005 to that in 2006?
Offer a very short reply. 1.01. What is the ratio of the Gross enrolment ratio (%) in Azerbaijan in 2005 to that in 2006?
Provide a short and direct response. 1.01. What is the ratio of the Gross enrolment ratio (%) of Guinea-Bissau in 2005 to that in 2006?
Offer a terse response. 0.95. What is the ratio of the Gross enrolment ratio (%) of Latvia in 2005 to that in 2006?
Ensure brevity in your answer.  0.99. What is the ratio of the Gross enrolment ratio (%) of Latin America(developing only) in 2005 to that in 2010?
Give a very brief answer. 1.04. What is the ratio of the Gross enrolment ratio (%) of Azerbaijan in 2005 to that in 2010?
Your response must be concise. 1.02. What is the ratio of the Gross enrolment ratio (%) in Guinea-Bissau in 2005 to that in 2010?
Offer a terse response. 0.98. What is the ratio of the Gross enrolment ratio (%) of Latvia in 2005 to that in 2010?
Provide a succinct answer. 0.88. What is the ratio of the Gross enrolment ratio (%) of Latin America(developing only) in 2006 to that in 2010?
Your answer should be very brief. 1.04. What is the ratio of the Gross enrolment ratio (%) of Guinea-Bissau in 2006 to that in 2010?
Your answer should be very brief. 1.03. What is the ratio of the Gross enrolment ratio (%) in Latvia in 2006 to that in 2010?
Ensure brevity in your answer.  0.9. What is the difference between the highest and the second highest Gross enrolment ratio (%) of Latin America(developing only)?
Ensure brevity in your answer.  1.09. What is the difference between the highest and the second highest Gross enrolment ratio (%) of Azerbaijan?
Offer a very short reply. 1.6. What is the difference between the highest and the second highest Gross enrolment ratio (%) of Guinea-Bissau?
Your answer should be very brief. 3.7. What is the difference between the highest and the second highest Gross enrolment ratio (%) of Latvia?
Your answer should be very brief. 5.63. What is the difference between the highest and the lowest Gross enrolment ratio (%) of Latin America(developing only)?
Make the answer very short. 10.01. What is the difference between the highest and the lowest Gross enrolment ratio (%) of Azerbaijan?
Your answer should be compact. 5.1. What is the difference between the highest and the lowest Gross enrolment ratio (%) of Guinea-Bissau?
Provide a short and direct response. 43.95. What is the difference between the highest and the lowest Gross enrolment ratio (%) of Latvia?
Offer a terse response. 12.39. 